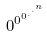<formula> <loc_0><loc_0><loc_500><loc_500>0 ^ { 0 ^ { 0 ^ { . ^ { . ^ { n } } } } }</formula> 